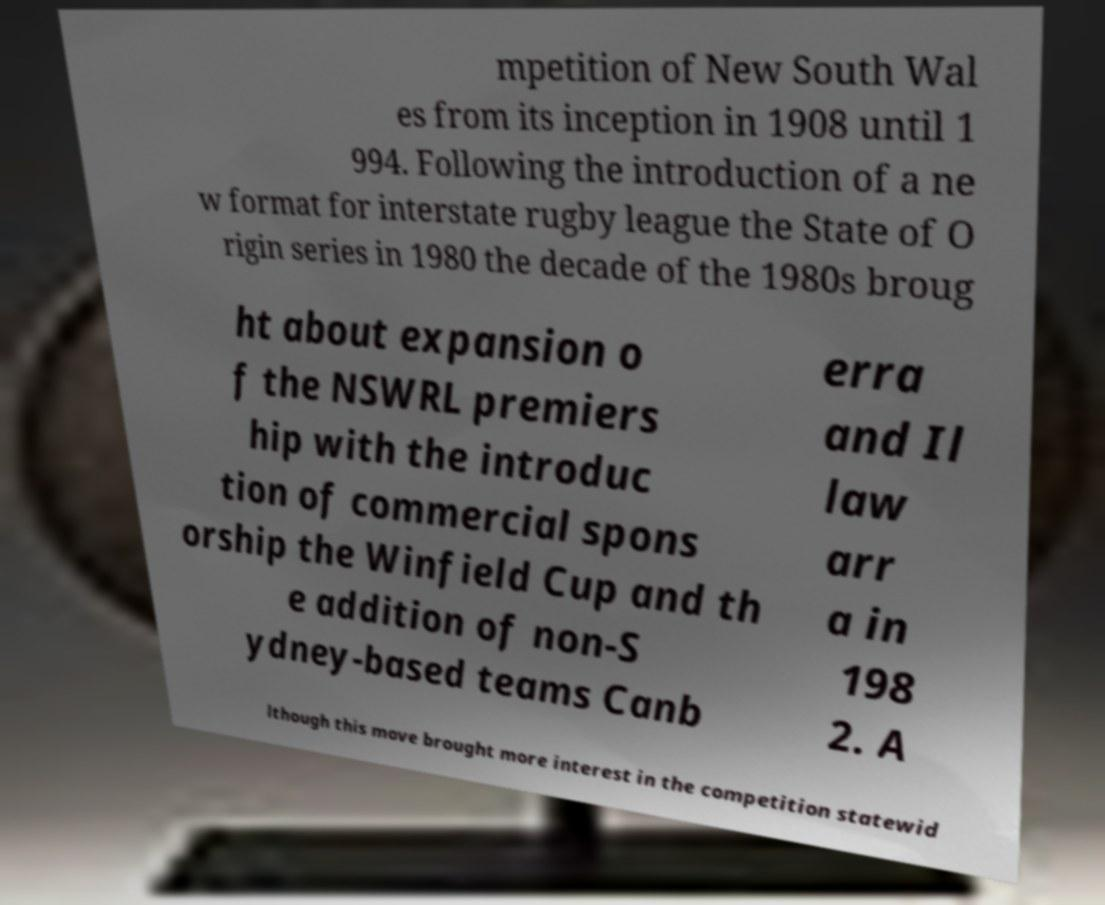Could you assist in decoding the text presented in this image and type it out clearly? mpetition of New South Wal es from its inception in 1908 until 1 994. Following the introduction of a ne w format for interstate rugby league the State of O rigin series in 1980 the decade of the 1980s broug ht about expansion o f the NSWRL premiers hip with the introduc tion of commercial spons orship the Winfield Cup and th e addition of non-S ydney-based teams Canb erra and Il law arr a in 198 2. A lthough this move brought more interest in the competition statewid 